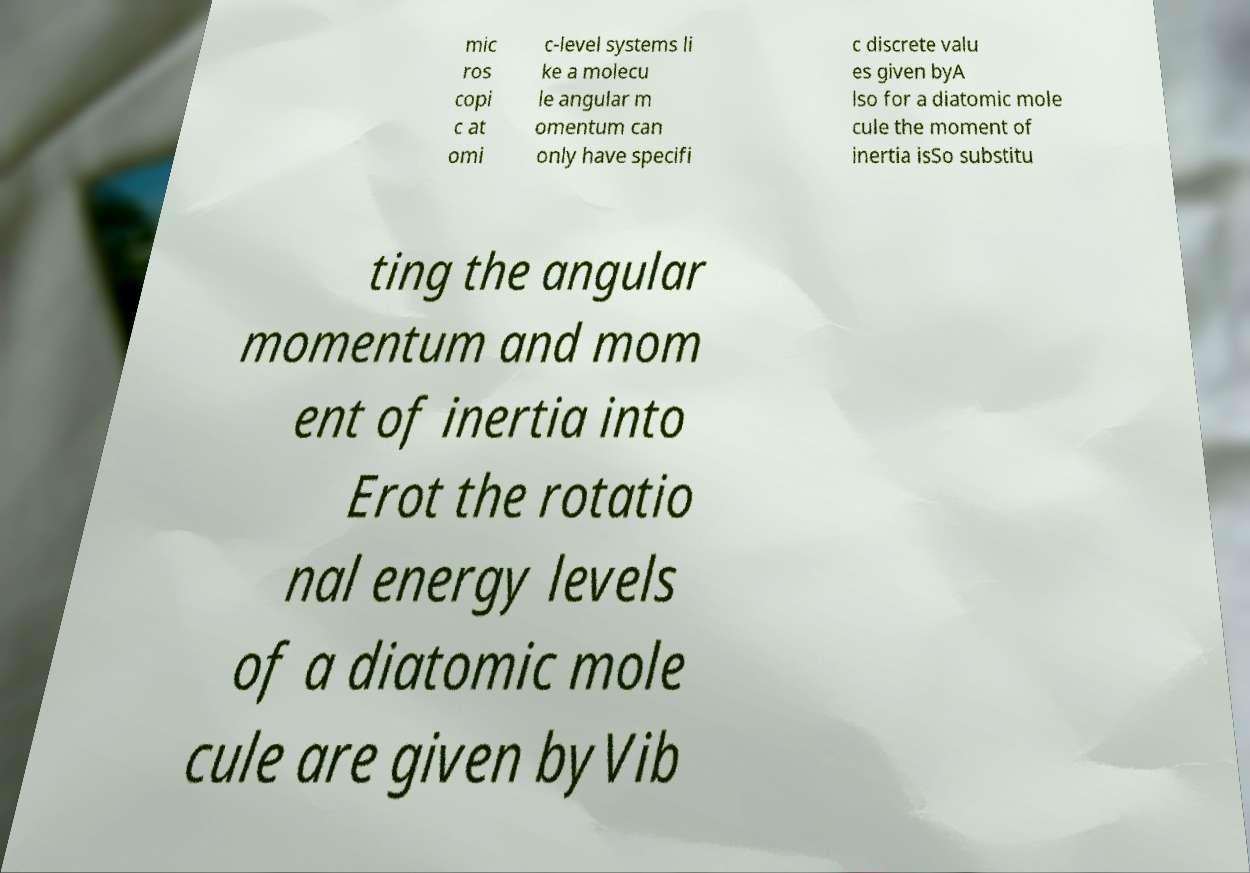Could you extract and type out the text from this image? mic ros copi c at omi c-level systems li ke a molecu le angular m omentum can only have specifi c discrete valu es given byA lso for a diatomic mole cule the moment of inertia isSo substitu ting the angular momentum and mom ent of inertia into Erot the rotatio nal energy levels of a diatomic mole cule are given byVib 